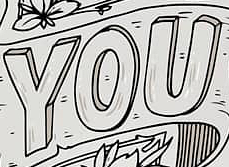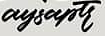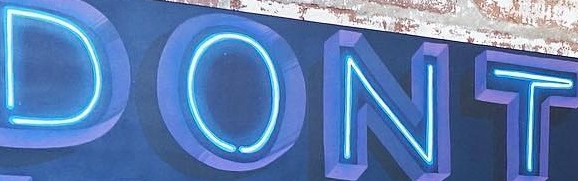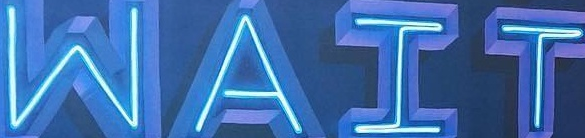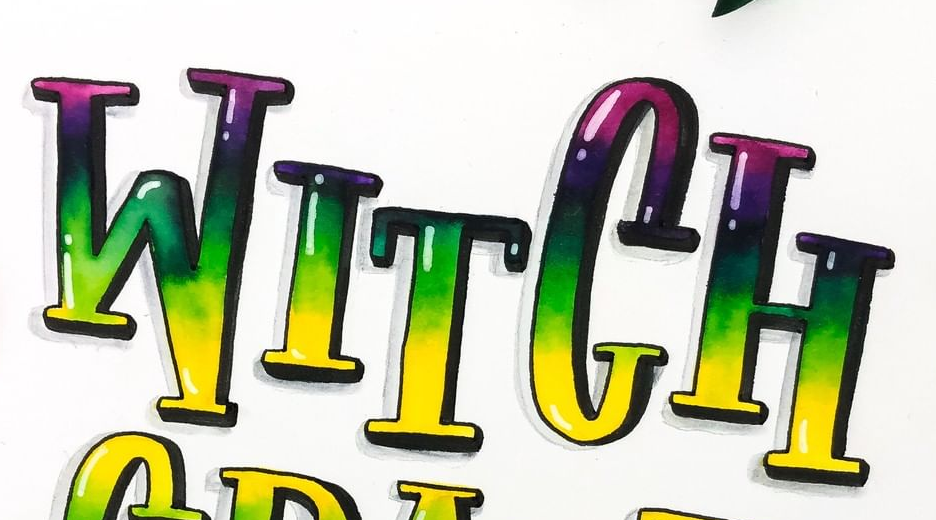Read the text from these images in sequence, separated by a semicolon. YOU; aysaptr; DONT; WAIT; WITCH 